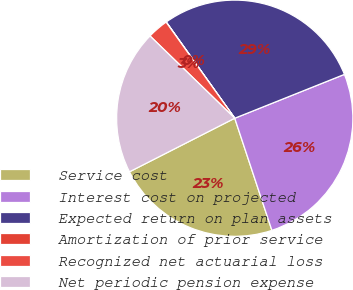Convert chart to OTSL. <chart><loc_0><loc_0><loc_500><loc_500><pie_chart><fcel>Service cost<fcel>Interest cost on projected<fcel>Expected return on plan assets<fcel>Amortization of prior service<fcel>Recognized net actuarial loss<fcel>Net periodic pension expense<nl><fcel>22.6%<fcel>25.96%<fcel>28.79%<fcel>0.03%<fcel>2.86%<fcel>19.76%<nl></chart> 